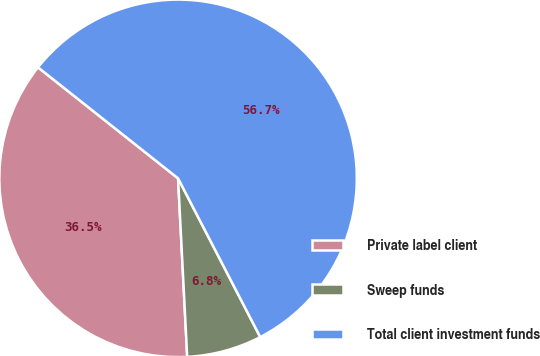Convert chart to OTSL. <chart><loc_0><loc_0><loc_500><loc_500><pie_chart><fcel>Private label client<fcel>Sweep funds<fcel>Total client investment funds<nl><fcel>36.48%<fcel>6.79%<fcel>56.73%<nl></chart> 